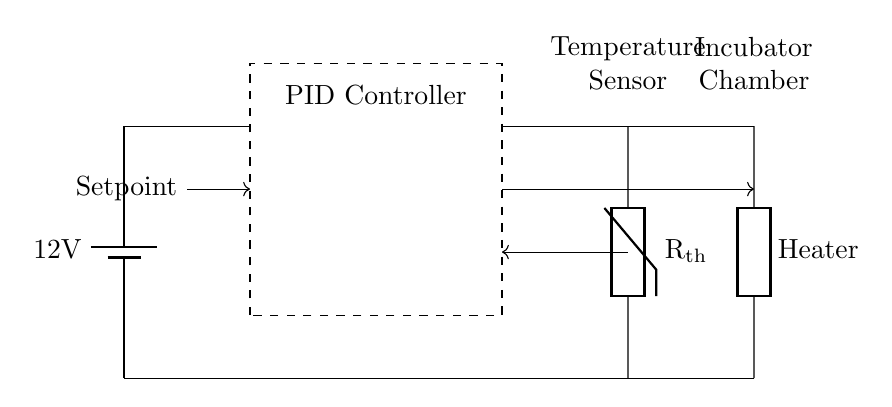What is the voltage of the power supply in the circuit? The circuit diagram shows a battery with the label indicating a voltage of twelve volts. Therefore, the voltage of the power supply is twelve volts.
Answer: twelve volts What component is represented by the dashed rectangle? The dashed rectangle is labeled as the PID Controller, which means it is the part of the circuit responsible for controlling the process variables based on input from the thermistor.
Answer: PID Controller How many components are directly related to temperature measurement in this circuit? The circuit includes only one temperature measurement component, which is the thermistor, as indicated in its labeling and connection to the PID controller.
Answer: one What type of control mechanism is used in this incubator circuit? The circuit employs a PID (Proportional-Integral-Derivative) control mechanism to maintain the desired temperature setpoint. The connections to the thermistor and heater support this control strategy.
Answer: PID What is the direction of the feedback loop in this circuit? The feedback loop, denoted by the arrow, runs from the thermistor towards the PID Controller, indicating that temperature readings from the thermistor are sent back to the controller for processing.
Answer: from thermistor to PID Controller Which component receives the setpoint input? The setpoint input is directed towards the PID Controller, suggesting that this is where the desired temperature is communicated for control purposes.
Answer: PID Controller 